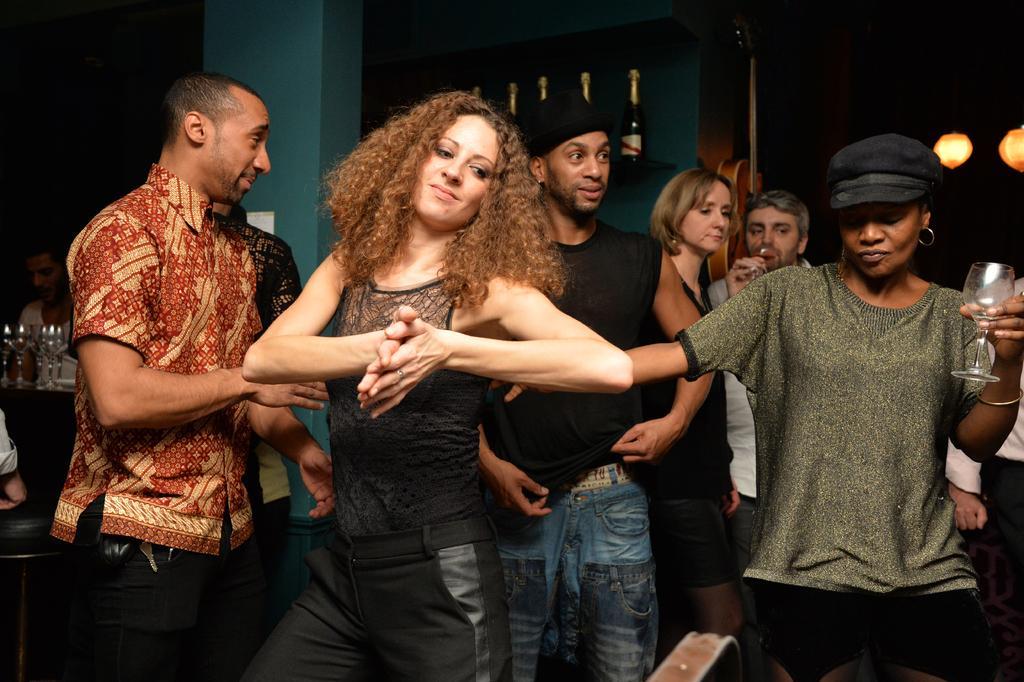Describe this image in one or two sentences. In the image we can see there are people standing and in front there is a woman holding a wine glass in her hand and there are wine bottles on the rack. 